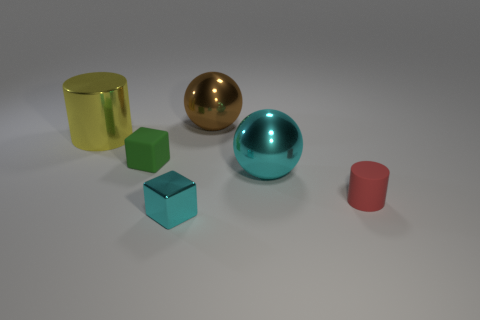Is the size of the metallic cylinder the same as the sphere in front of the big yellow cylinder?
Your answer should be very brief. Yes. What number of objects are small rubber things in front of the tiny green rubber cube or large metal objects that are right of the green rubber object?
Keep it short and to the point. 3. The rubber object that is the same size as the green rubber cube is what shape?
Provide a succinct answer. Cylinder. What shape is the cyan object that is in front of the sphere in front of the tiny rubber object that is behind the red matte cylinder?
Offer a very short reply. Cube. Is the number of cylinders in front of the cyan metal block the same as the number of tiny cyan matte blocks?
Your answer should be compact. Yes. Do the green cube and the red cylinder have the same size?
Offer a very short reply. Yes. How many shiny objects are yellow things or brown objects?
Ensure brevity in your answer.  2. There is a red cylinder that is the same size as the green matte cube; what is it made of?
Your response must be concise. Rubber. How many other objects are there of the same material as the small green thing?
Offer a very short reply. 1. Are there fewer shiny objects that are behind the brown thing than small matte cubes?
Make the answer very short. Yes. 